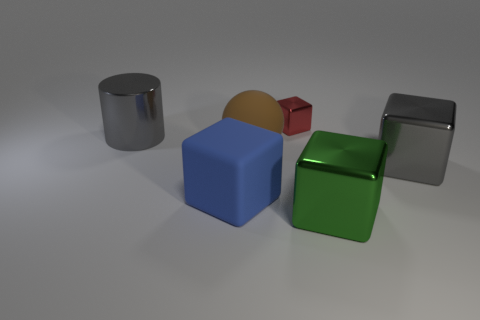Subtract 1 cubes. How many cubes are left? 3 Add 1 rubber blocks. How many objects exist? 7 Subtract all cubes. How many objects are left? 2 Subtract all large brown rubber things. Subtract all gray rubber things. How many objects are left? 5 Add 1 green things. How many green things are left? 2 Add 5 gray objects. How many gray objects exist? 7 Subtract 0 green spheres. How many objects are left? 6 